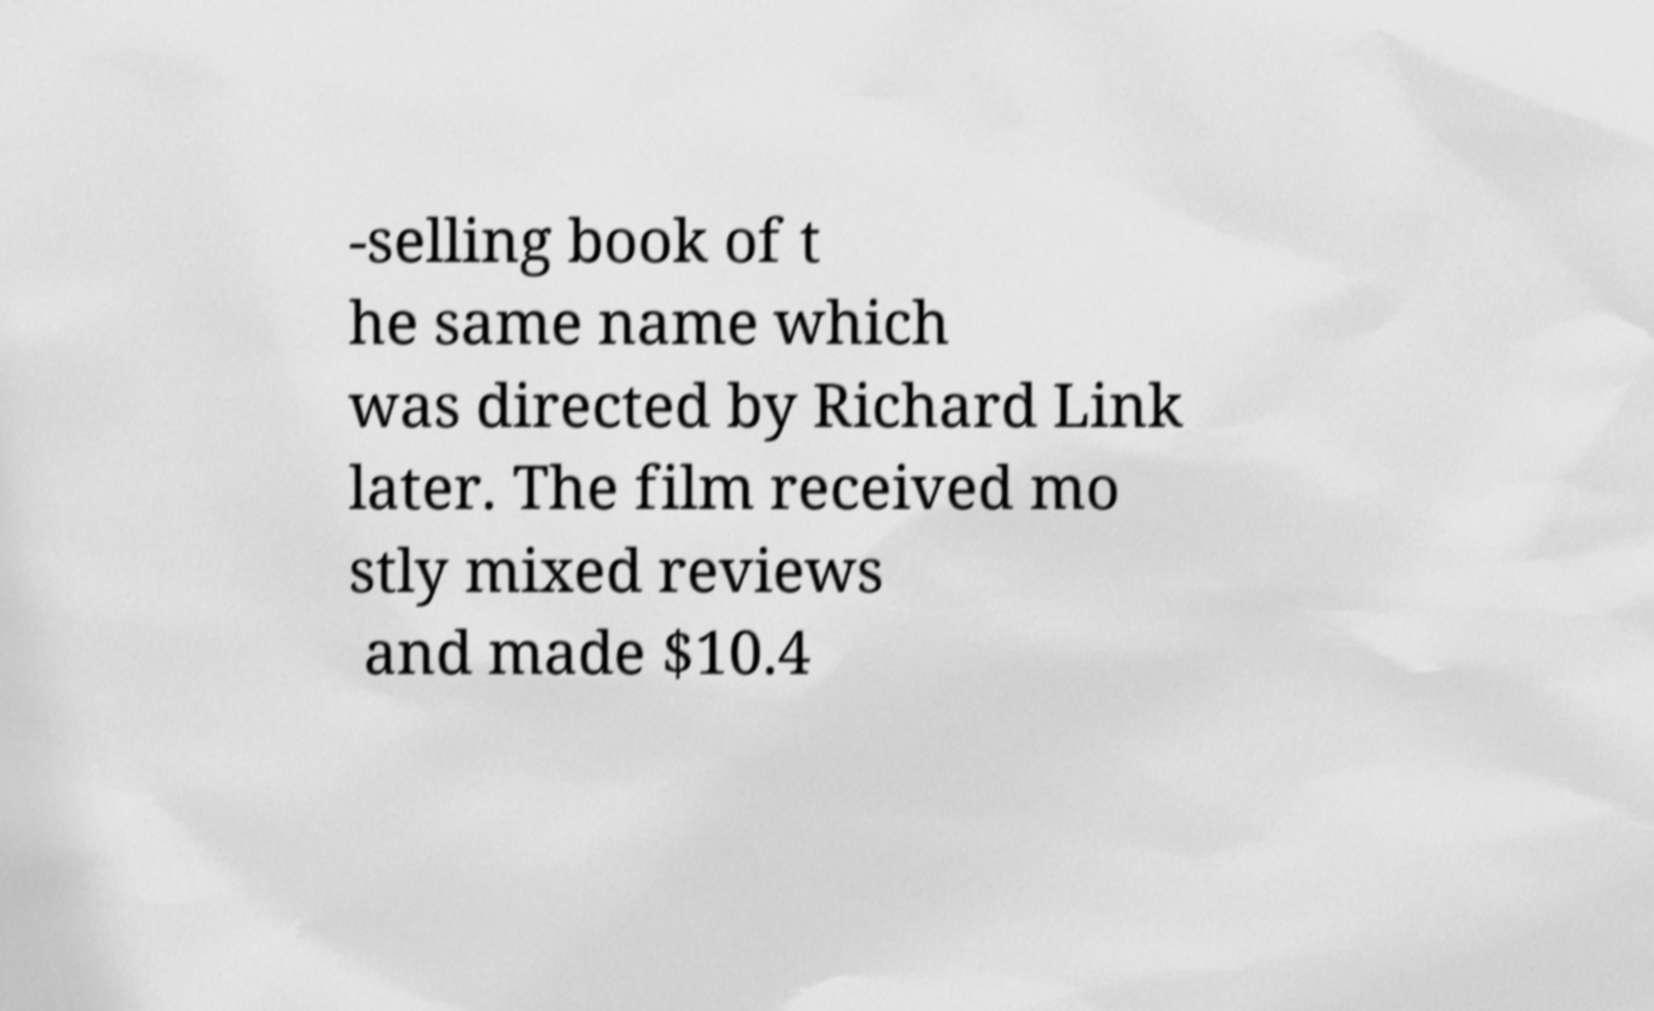I need the written content from this picture converted into text. Can you do that? -selling book of t he same name which was directed by Richard Link later. The film received mo stly mixed reviews and made $10.4 